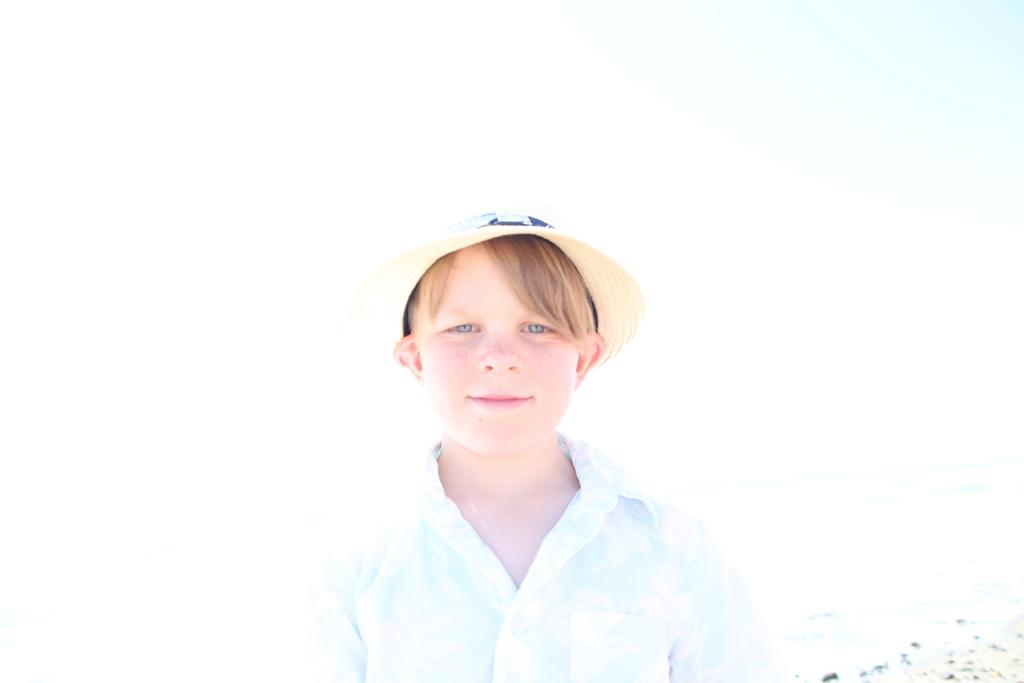Who is the main subject in the image? There is a boy in the image. What is the boy wearing on his head? The boy is wearing a cap. What type of berry is the boy holding in the image? There is no berry present in the image; the boy is only wearing a cap. 